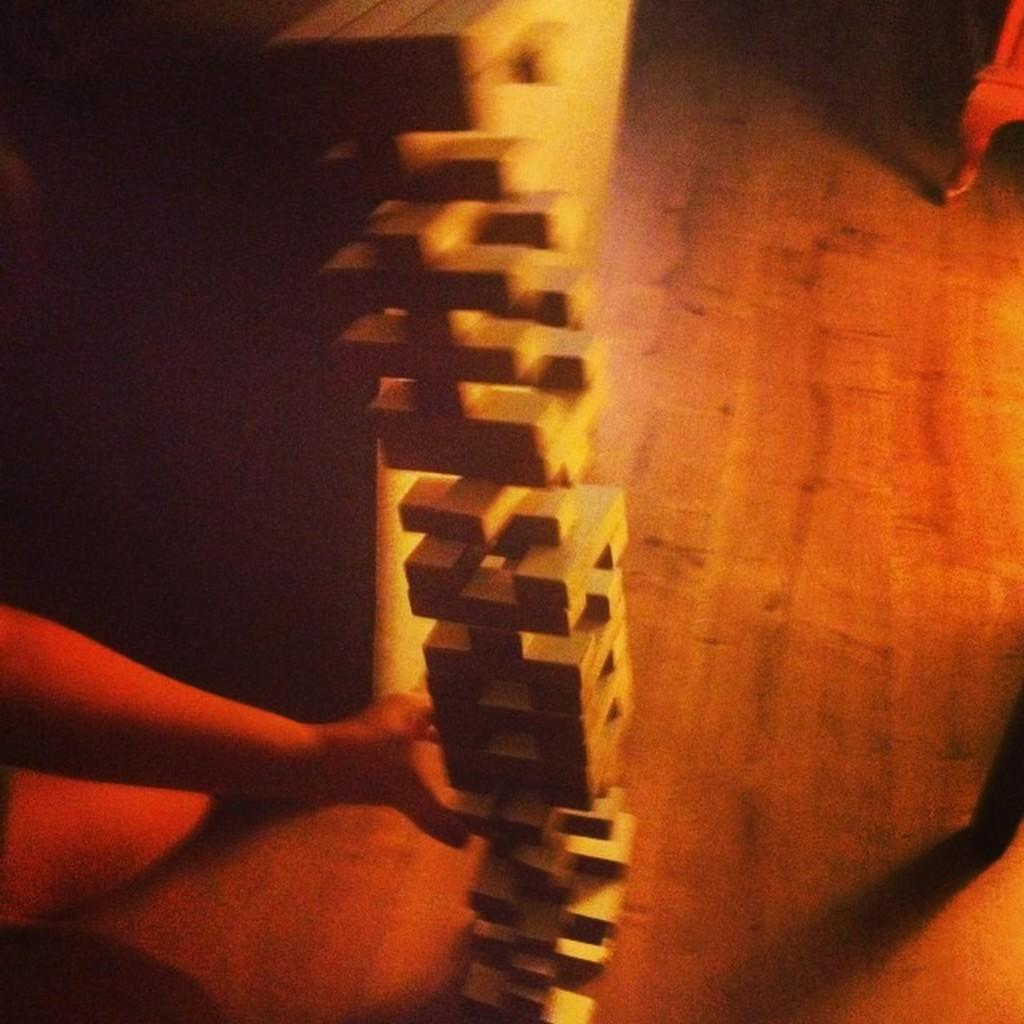What type of game is being played in the image? There is a wooden block stacking game in the image. Whose hand is visible in the image? A person's hand is visible in the image. What is the surface on which the game is being played? There is a wooden floor in the image. Can you describe the objects present in the image? There are wooden blocks, which are part of the stacking game, and a person's hand. What type of knot is being tied on the hill in the image? There is no knot or hill present in the image; it features a wooden block stacking game and a person's hand. What type of table is being used to play the game in the image? There is no table present in the image; the game is being played on a wooden floor. 